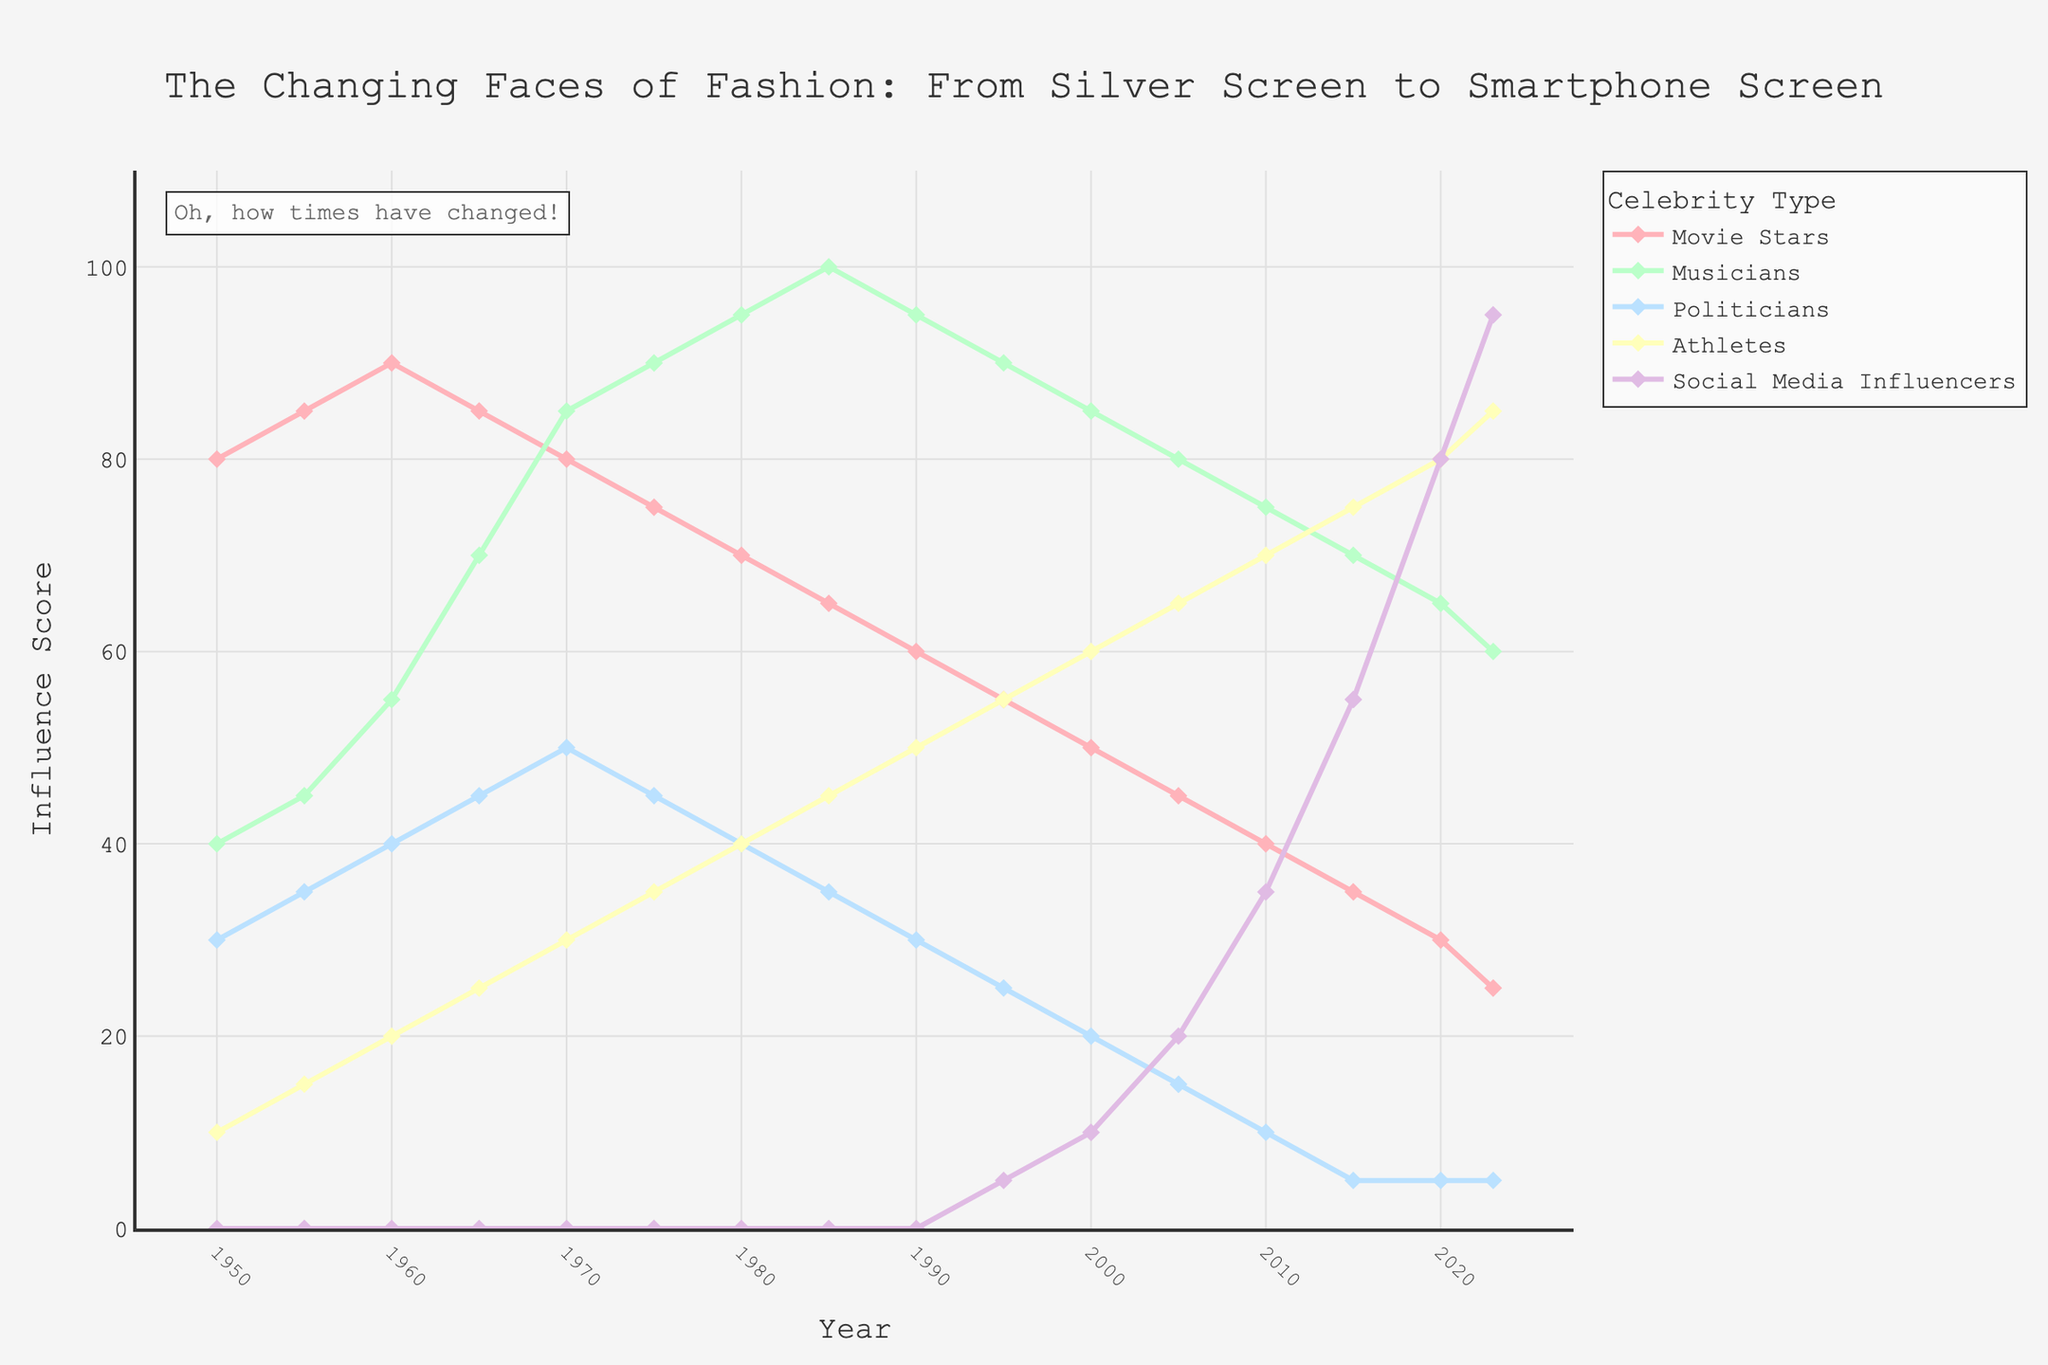what is the trend in the influence score of movie stars from 1950 to 2023? Movie stars' influence starts high in 1950 at 80 and gradually declines to 25 by 2023. The trend is a consistent downward slope.
Answer: It declines how does the influence of musicians in 1970 compare to their influence in 2023? Musicians had a peak influence score of 85 in 1970, which decreases to 60 by 2023.
Answer: Higher in 1970 Who showed the most dramatic increase in influence from 2005 to 2023? Social media influencers show the most dramatic increase by going from 20 in 2005 to 95 in 2023.
Answer: Social media influencers what category had the most stable influence over the years without drastic fluctuations? Politicians show the most stability, remaining relatively low but steady around 30-5 without drastic increases or decreases.
Answer: Politicians By how much did athletes' influence increase from 1950 to 2023? Athletes' influence increased from 10 in 1950 to 85 in 2023, therefore increasing by 75 points.
Answer: 75 points Which category had the highest influence in 1990, and what was the score? Musicians had the highest influence in 1990 with an influence score of 95.
Answer: Musicians with 95 Compare and contrast the influence trends of social media influencers and movie stars from 1990 to 2023. While social media influencers started from 0 in 1990 and grew dramatically to 95 in 2023, movie stars declined from 60 to 25 over the same period.
Answer: Influencers up, movie stars down What visual elements distinguish the trend of musicians' influence from the rest? Musicians' trend line is colored green and shows a steady rise from 1950 to the peak in 1985, then slowly drops while other categories don't have similar steady long-term patterns.
Answer: Green line, steady rise then drop Which category saw the fastest rise in influence over the shortest period? Social media influencers saw the fastest rise, particularly from 2015 to 2023, going from 55 to 95 in just 8 years.
Answer: Social media influencers 